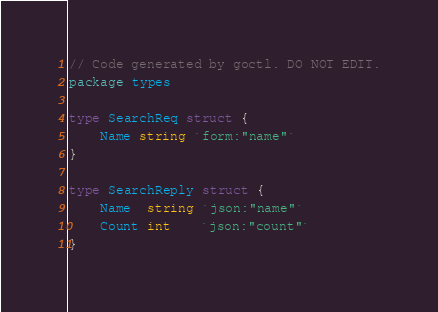Convert code to text. <code><loc_0><loc_0><loc_500><loc_500><_Go_>// Code generated by goctl. DO NOT EDIT.
package types

type SearchReq struct {
	Name string `form:"name"`
}

type SearchReply struct {
	Name  string `json:"name"`
	Count int    `json:"count"`
}
</code> 